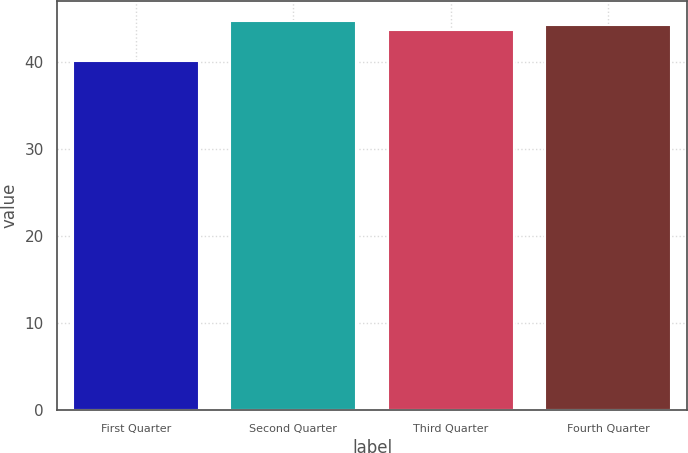Convert chart to OTSL. <chart><loc_0><loc_0><loc_500><loc_500><bar_chart><fcel>First Quarter<fcel>Second Quarter<fcel>Third Quarter<fcel>Fourth Quarter<nl><fcel>40.12<fcel>44.73<fcel>43.65<fcel>44.29<nl></chart> 